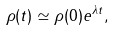<formula> <loc_0><loc_0><loc_500><loc_500>\rho ( t ) \simeq \rho ( 0 ) e ^ { \lambda t } ,</formula> 